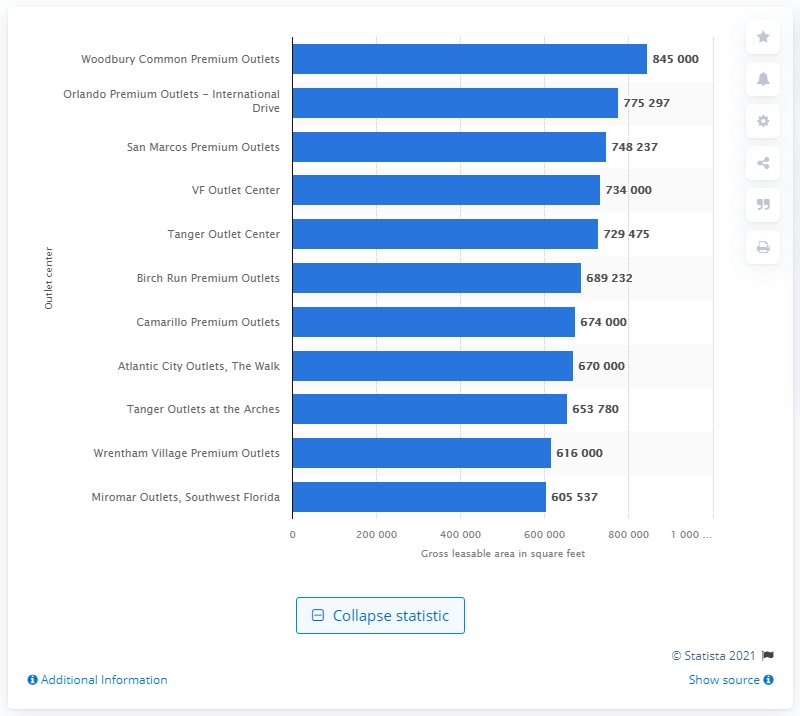Give some essential details in this illustration. In 2011, Woodbury Common Premium Outlets was the largest outlet center in the Americas. 